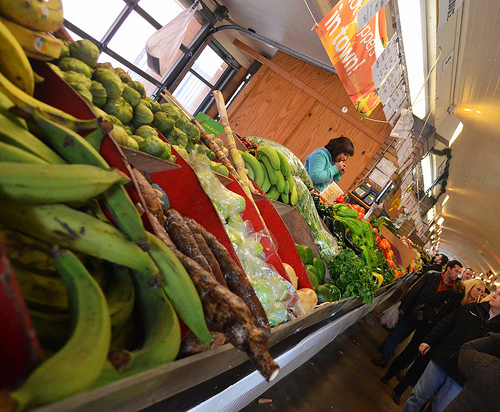<image>
Is there a man behind the bananas? No. The man is not behind the bananas. From this viewpoint, the man appears to be positioned elsewhere in the scene. 